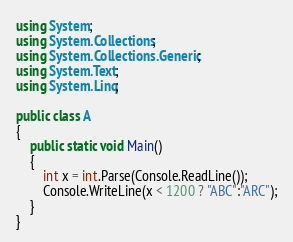Convert code to text. <code><loc_0><loc_0><loc_500><loc_500><_C#_>using System;
using System.Collections;
using System.Collections.Generic;
using System.Text;
using System.Linq;

public class A
{
    public static void Main()
    {
        int x = int.Parse(Console.ReadLine());
        Console.WriteLine(x < 1200 ? "ABC":"ARC");
    }
}
</code> 